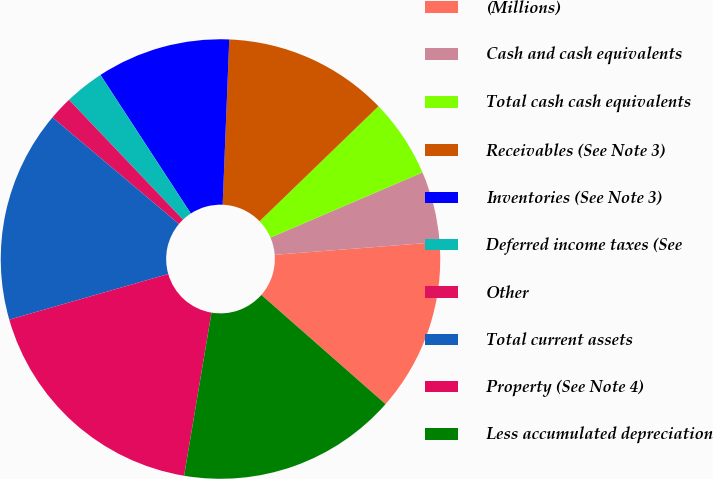<chart> <loc_0><loc_0><loc_500><loc_500><pie_chart><fcel>(Millions)<fcel>Cash and cash equivalents<fcel>Total cash cash equivalents<fcel>Receivables (See Note 3)<fcel>Inventories (See Note 3)<fcel>Deferred income taxes (See<fcel>Other<fcel>Total current assets<fcel>Property (See Note 4)<fcel>Less accumulated depreciation<nl><fcel>12.71%<fcel>5.21%<fcel>5.79%<fcel>12.13%<fcel>9.83%<fcel>2.91%<fcel>1.75%<fcel>15.59%<fcel>17.9%<fcel>16.17%<nl></chart> 